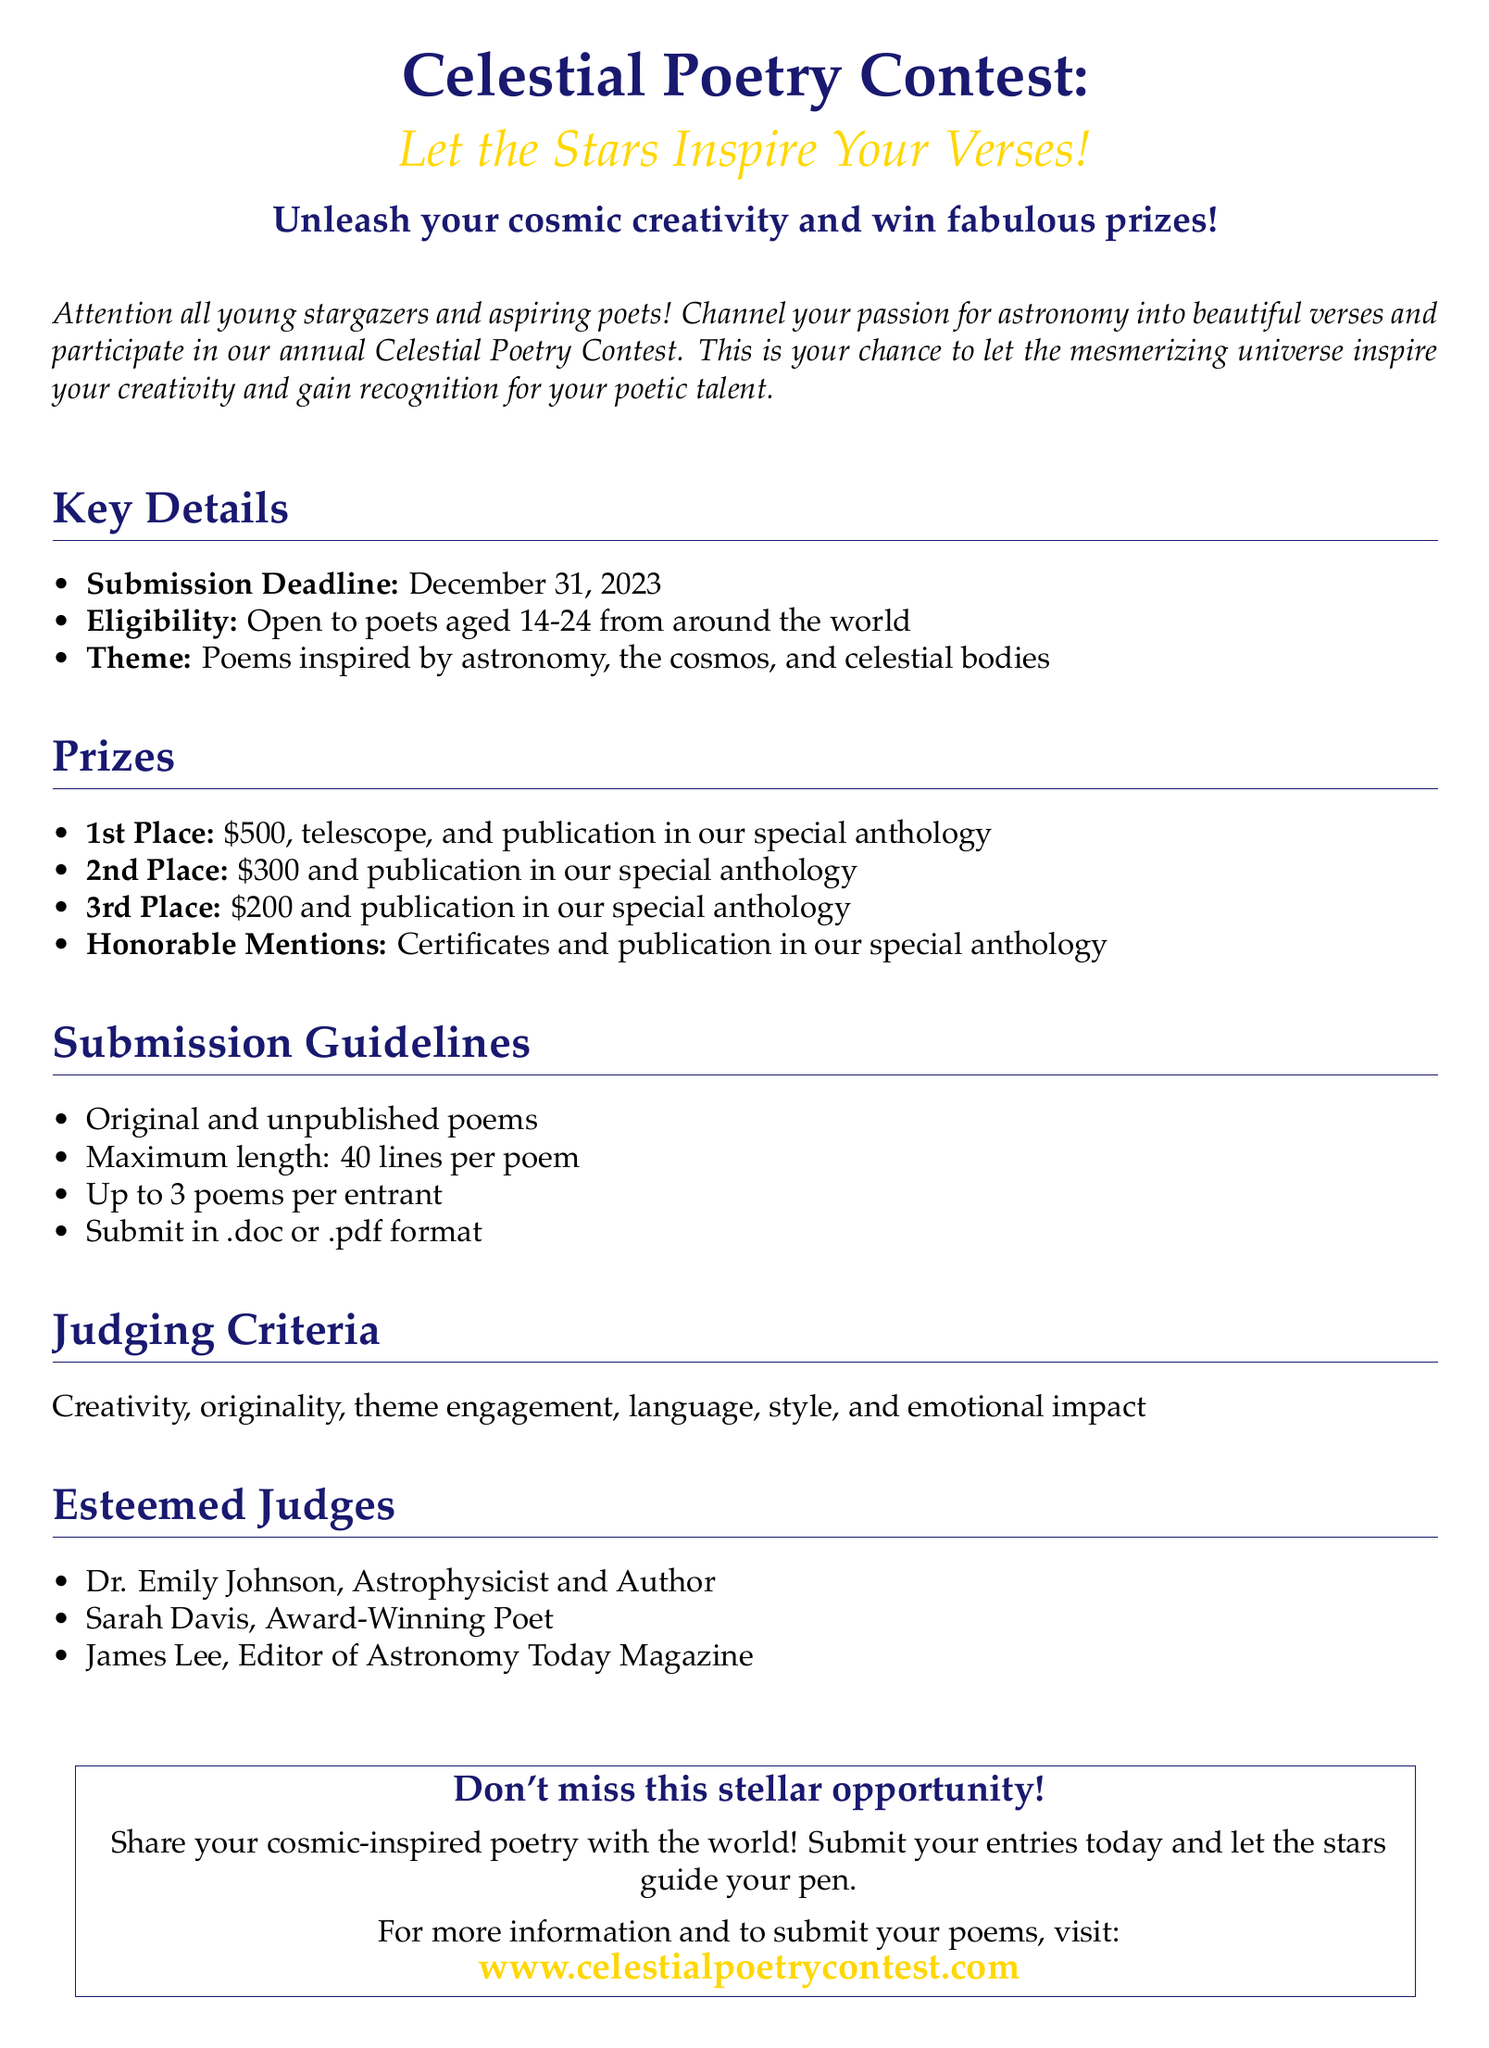What is the submission deadline? The submission deadline for the contest is mentioned in the "Key Details" section.
Answer: December 31, 2023 Who is eligible to participate? The eligibility criteria are specified in the "Key Details" section, stating the age range of participants.
Answer: Poets aged 14-24 What is the maximum length for each poem? The maximum length of poems is outlined in the "Submission Guidelines."
Answer: 40 lines What prize does the 1st place winner receive? The prizes for each position are listed in the "Prizes" section, detailing the rewards for the top winner.
Answer: $500, telescope, and publication How many poems can each entrant submit? The number of poems per entrant is stated in the "Submission Guidelines."
Answer: Up to 3 poems Who are the judges of the contest? The judges of the contest are listed in the "Esteemed Judges" section, providing their names and titles.
Answer: Dr. Emily Johnson, Sarah Davis, James Lee What is the theme for the contest? The theme for the contest is specified in the "Key Details" section, highlighting the inspirational aspect.
Answer: Poems inspired by astronomy, the cosmos, and celestial bodies What type of poems are accepted? The type of poems allowed is mentioned in the "Submission Guidelines" as a requirement for participants.
Answer: Original and unpublished poems 